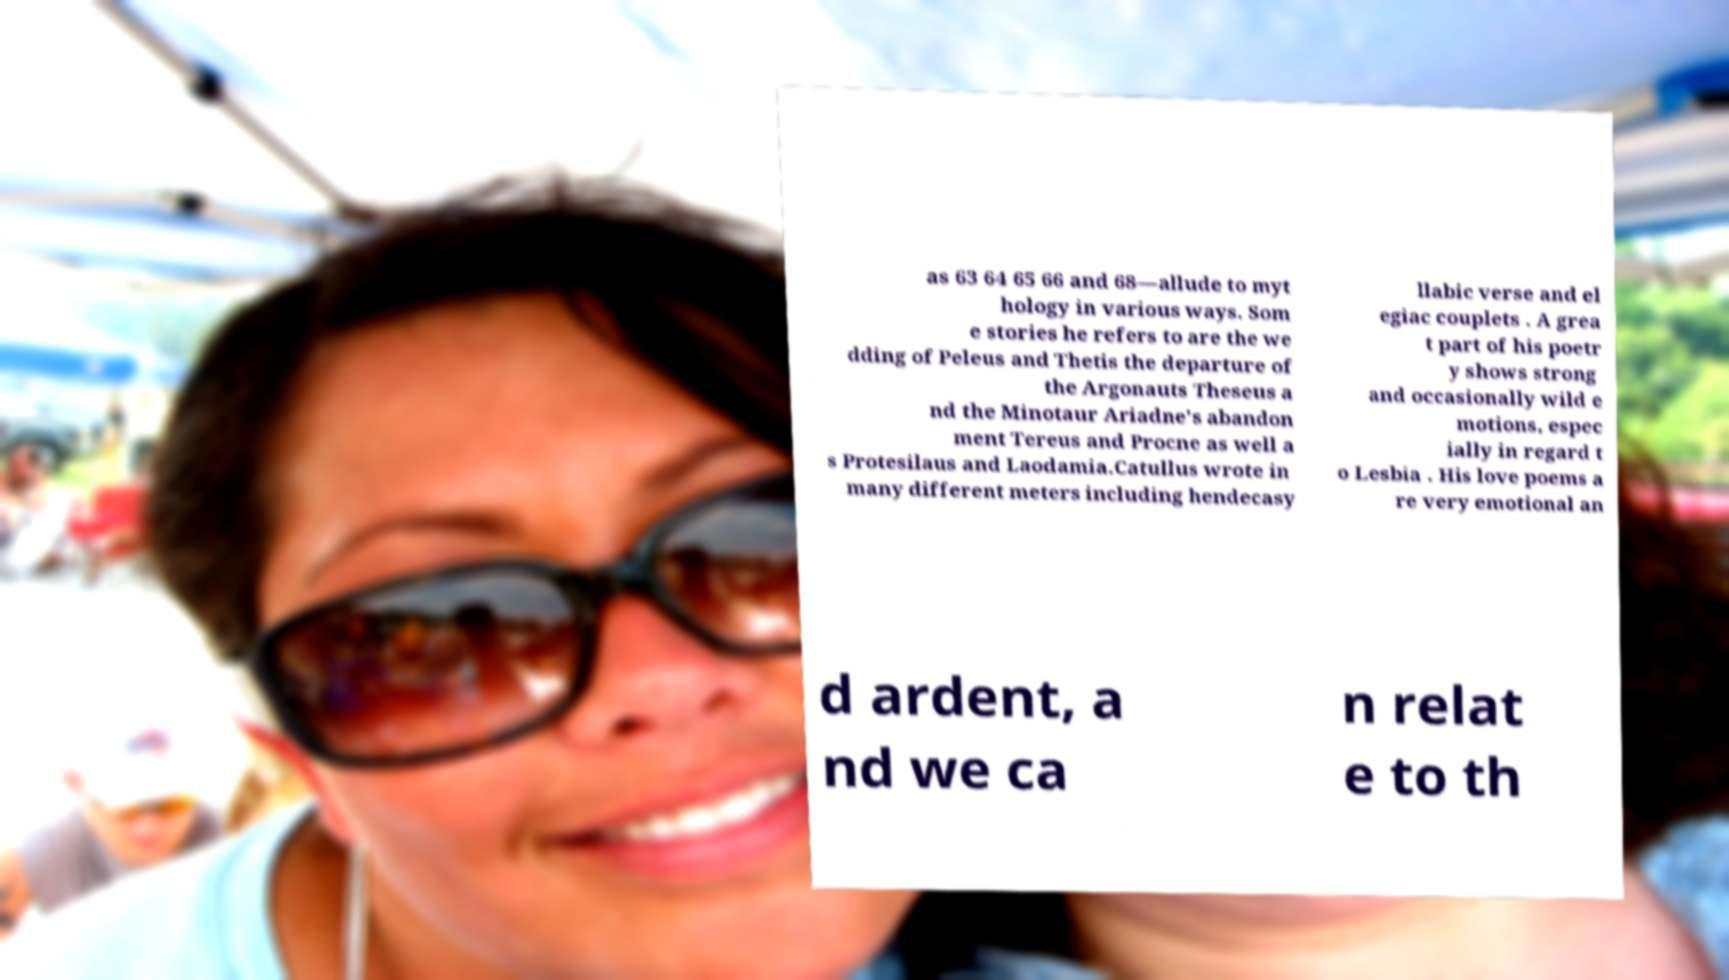Please read and relay the text visible in this image. What does it say? as 63 64 65 66 and 68—allude to myt hology in various ways. Som e stories he refers to are the we dding of Peleus and Thetis the departure of the Argonauts Theseus a nd the Minotaur Ariadne's abandon ment Tereus and Procne as well a s Protesilaus and Laodamia.Catullus wrote in many different meters including hendecasy llabic verse and el egiac couplets . A grea t part of his poetr y shows strong and occasionally wild e motions, espec ially in regard t o Lesbia . His love poems a re very emotional an d ardent, a nd we ca n relat e to th 